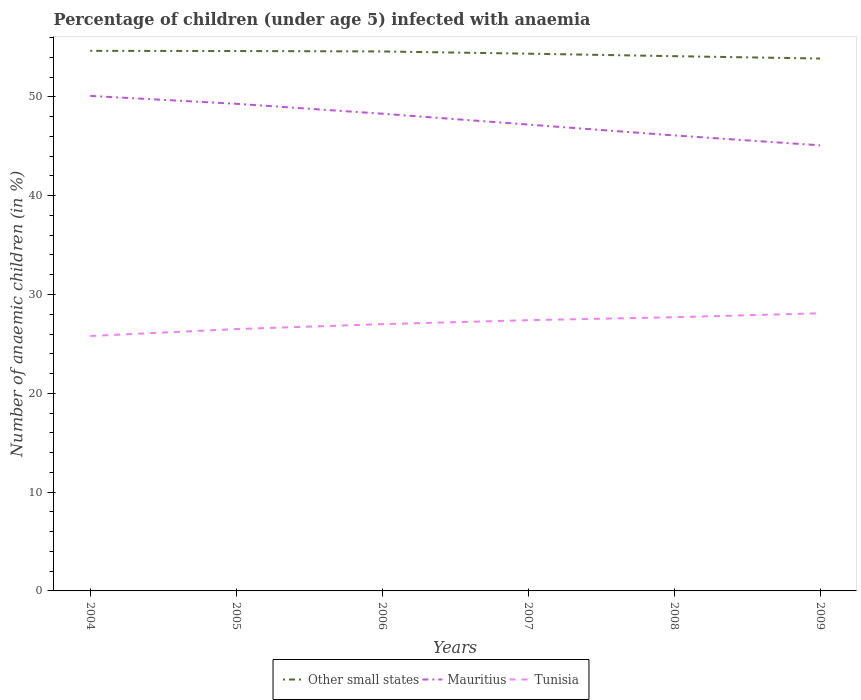How many different coloured lines are there?
Provide a short and direct response. 3. Does the line corresponding to Other small states intersect with the line corresponding to Mauritius?
Offer a very short reply. No. Across all years, what is the maximum percentage of children infected with anaemia in in Mauritius?
Your answer should be compact. 45.1. What is the total percentage of children infected with anaemia in in Mauritius in the graph?
Your answer should be compact. 2.9. What is the difference between the highest and the second highest percentage of children infected with anaemia in in Other small states?
Offer a very short reply. 0.78. Is the percentage of children infected with anaemia in in Mauritius strictly greater than the percentage of children infected with anaemia in in Tunisia over the years?
Offer a very short reply. No. How many lines are there?
Your response must be concise. 3. What is the difference between two consecutive major ticks on the Y-axis?
Provide a succinct answer. 10. Are the values on the major ticks of Y-axis written in scientific E-notation?
Your answer should be compact. No. Does the graph contain grids?
Offer a terse response. No. Where does the legend appear in the graph?
Offer a very short reply. Bottom center. What is the title of the graph?
Offer a terse response. Percentage of children (under age 5) infected with anaemia. What is the label or title of the X-axis?
Ensure brevity in your answer.  Years. What is the label or title of the Y-axis?
Give a very brief answer. Number of anaemic children (in %). What is the Number of anaemic children (in %) of Other small states in 2004?
Your answer should be very brief. 54.66. What is the Number of anaemic children (in %) of Mauritius in 2004?
Offer a very short reply. 50.1. What is the Number of anaemic children (in %) in Tunisia in 2004?
Give a very brief answer. 25.8. What is the Number of anaemic children (in %) in Other small states in 2005?
Your response must be concise. 54.64. What is the Number of anaemic children (in %) in Mauritius in 2005?
Provide a short and direct response. 49.3. What is the Number of anaemic children (in %) of Tunisia in 2005?
Keep it short and to the point. 26.5. What is the Number of anaemic children (in %) in Other small states in 2006?
Make the answer very short. 54.6. What is the Number of anaemic children (in %) in Mauritius in 2006?
Give a very brief answer. 48.3. What is the Number of anaemic children (in %) in Other small states in 2007?
Provide a short and direct response. 54.37. What is the Number of anaemic children (in %) in Mauritius in 2007?
Provide a short and direct response. 47.2. What is the Number of anaemic children (in %) in Tunisia in 2007?
Make the answer very short. 27.4. What is the Number of anaemic children (in %) of Other small states in 2008?
Keep it short and to the point. 54.12. What is the Number of anaemic children (in %) of Mauritius in 2008?
Ensure brevity in your answer.  46.1. What is the Number of anaemic children (in %) of Tunisia in 2008?
Provide a short and direct response. 27.7. What is the Number of anaemic children (in %) in Other small states in 2009?
Provide a succinct answer. 53.88. What is the Number of anaemic children (in %) in Mauritius in 2009?
Offer a very short reply. 45.1. What is the Number of anaemic children (in %) of Tunisia in 2009?
Provide a short and direct response. 28.1. Across all years, what is the maximum Number of anaemic children (in %) of Other small states?
Provide a short and direct response. 54.66. Across all years, what is the maximum Number of anaemic children (in %) of Mauritius?
Offer a terse response. 50.1. Across all years, what is the maximum Number of anaemic children (in %) of Tunisia?
Offer a very short reply. 28.1. Across all years, what is the minimum Number of anaemic children (in %) in Other small states?
Keep it short and to the point. 53.88. Across all years, what is the minimum Number of anaemic children (in %) of Mauritius?
Provide a short and direct response. 45.1. Across all years, what is the minimum Number of anaemic children (in %) in Tunisia?
Offer a terse response. 25.8. What is the total Number of anaemic children (in %) in Other small states in the graph?
Give a very brief answer. 326.28. What is the total Number of anaemic children (in %) of Mauritius in the graph?
Provide a succinct answer. 286.1. What is the total Number of anaemic children (in %) in Tunisia in the graph?
Your answer should be compact. 162.5. What is the difference between the Number of anaemic children (in %) in Other small states in 2004 and that in 2005?
Your answer should be very brief. 0.02. What is the difference between the Number of anaemic children (in %) in Tunisia in 2004 and that in 2005?
Provide a short and direct response. -0.7. What is the difference between the Number of anaemic children (in %) of Other small states in 2004 and that in 2006?
Offer a terse response. 0.06. What is the difference between the Number of anaemic children (in %) in Other small states in 2004 and that in 2007?
Provide a short and direct response. 0.29. What is the difference between the Number of anaemic children (in %) in Mauritius in 2004 and that in 2007?
Provide a succinct answer. 2.9. What is the difference between the Number of anaemic children (in %) in Other small states in 2004 and that in 2008?
Offer a very short reply. 0.54. What is the difference between the Number of anaemic children (in %) in Mauritius in 2004 and that in 2008?
Provide a short and direct response. 4. What is the difference between the Number of anaemic children (in %) in Tunisia in 2004 and that in 2008?
Provide a succinct answer. -1.9. What is the difference between the Number of anaemic children (in %) of Other small states in 2004 and that in 2009?
Offer a very short reply. 0.78. What is the difference between the Number of anaemic children (in %) in Mauritius in 2004 and that in 2009?
Keep it short and to the point. 5. What is the difference between the Number of anaemic children (in %) in Tunisia in 2004 and that in 2009?
Ensure brevity in your answer.  -2.3. What is the difference between the Number of anaemic children (in %) in Other small states in 2005 and that in 2006?
Offer a very short reply. 0.04. What is the difference between the Number of anaemic children (in %) in Mauritius in 2005 and that in 2006?
Offer a terse response. 1. What is the difference between the Number of anaemic children (in %) in Tunisia in 2005 and that in 2006?
Your response must be concise. -0.5. What is the difference between the Number of anaemic children (in %) of Other small states in 2005 and that in 2007?
Keep it short and to the point. 0.27. What is the difference between the Number of anaemic children (in %) of Other small states in 2005 and that in 2008?
Ensure brevity in your answer.  0.52. What is the difference between the Number of anaemic children (in %) in Mauritius in 2005 and that in 2008?
Make the answer very short. 3.2. What is the difference between the Number of anaemic children (in %) in Tunisia in 2005 and that in 2008?
Provide a succinct answer. -1.2. What is the difference between the Number of anaemic children (in %) of Other small states in 2005 and that in 2009?
Your answer should be compact. 0.76. What is the difference between the Number of anaemic children (in %) in Mauritius in 2005 and that in 2009?
Your answer should be very brief. 4.2. What is the difference between the Number of anaemic children (in %) in Other small states in 2006 and that in 2007?
Make the answer very short. 0.23. What is the difference between the Number of anaemic children (in %) of Mauritius in 2006 and that in 2007?
Keep it short and to the point. 1.1. What is the difference between the Number of anaemic children (in %) in Tunisia in 2006 and that in 2007?
Give a very brief answer. -0.4. What is the difference between the Number of anaemic children (in %) in Other small states in 2006 and that in 2008?
Your answer should be very brief. 0.48. What is the difference between the Number of anaemic children (in %) of Other small states in 2006 and that in 2009?
Make the answer very short. 0.72. What is the difference between the Number of anaemic children (in %) of Tunisia in 2006 and that in 2009?
Your response must be concise. -1.1. What is the difference between the Number of anaemic children (in %) of Other small states in 2007 and that in 2008?
Provide a succinct answer. 0.25. What is the difference between the Number of anaemic children (in %) in Tunisia in 2007 and that in 2008?
Your answer should be compact. -0.3. What is the difference between the Number of anaemic children (in %) in Other small states in 2007 and that in 2009?
Keep it short and to the point. 0.49. What is the difference between the Number of anaemic children (in %) in Tunisia in 2007 and that in 2009?
Your response must be concise. -0.7. What is the difference between the Number of anaemic children (in %) of Other small states in 2008 and that in 2009?
Your answer should be compact. 0.24. What is the difference between the Number of anaemic children (in %) of Mauritius in 2008 and that in 2009?
Offer a very short reply. 1. What is the difference between the Number of anaemic children (in %) of Tunisia in 2008 and that in 2009?
Your answer should be very brief. -0.4. What is the difference between the Number of anaemic children (in %) in Other small states in 2004 and the Number of anaemic children (in %) in Mauritius in 2005?
Offer a very short reply. 5.36. What is the difference between the Number of anaemic children (in %) in Other small states in 2004 and the Number of anaemic children (in %) in Tunisia in 2005?
Your answer should be very brief. 28.16. What is the difference between the Number of anaemic children (in %) in Mauritius in 2004 and the Number of anaemic children (in %) in Tunisia in 2005?
Offer a very short reply. 23.6. What is the difference between the Number of anaemic children (in %) of Other small states in 2004 and the Number of anaemic children (in %) of Mauritius in 2006?
Offer a terse response. 6.36. What is the difference between the Number of anaemic children (in %) of Other small states in 2004 and the Number of anaemic children (in %) of Tunisia in 2006?
Provide a succinct answer. 27.66. What is the difference between the Number of anaemic children (in %) in Mauritius in 2004 and the Number of anaemic children (in %) in Tunisia in 2006?
Make the answer very short. 23.1. What is the difference between the Number of anaemic children (in %) in Other small states in 2004 and the Number of anaemic children (in %) in Mauritius in 2007?
Keep it short and to the point. 7.46. What is the difference between the Number of anaemic children (in %) in Other small states in 2004 and the Number of anaemic children (in %) in Tunisia in 2007?
Keep it short and to the point. 27.26. What is the difference between the Number of anaemic children (in %) of Mauritius in 2004 and the Number of anaemic children (in %) of Tunisia in 2007?
Your response must be concise. 22.7. What is the difference between the Number of anaemic children (in %) of Other small states in 2004 and the Number of anaemic children (in %) of Mauritius in 2008?
Provide a short and direct response. 8.56. What is the difference between the Number of anaemic children (in %) of Other small states in 2004 and the Number of anaemic children (in %) of Tunisia in 2008?
Provide a succinct answer. 26.96. What is the difference between the Number of anaemic children (in %) of Mauritius in 2004 and the Number of anaemic children (in %) of Tunisia in 2008?
Make the answer very short. 22.4. What is the difference between the Number of anaemic children (in %) in Other small states in 2004 and the Number of anaemic children (in %) in Mauritius in 2009?
Provide a short and direct response. 9.56. What is the difference between the Number of anaemic children (in %) in Other small states in 2004 and the Number of anaemic children (in %) in Tunisia in 2009?
Your answer should be compact. 26.56. What is the difference between the Number of anaemic children (in %) in Mauritius in 2004 and the Number of anaemic children (in %) in Tunisia in 2009?
Give a very brief answer. 22. What is the difference between the Number of anaemic children (in %) in Other small states in 2005 and the Number of anaemic children (in %) in Mauritius in 2006?
Your response must be concise. 6.34. What is the difference between the Number of anaemic children (in %) of Other small states in 2005 and the Number of anaemic children (in %) of Tunisia in 2006?
Your answer should be compact. 27.64. What is the difference between the Number of anaemic children (in %) of Mauritius in 2005 and the Number of anaemic children (in %) of Tunisia in 2006?
Your response must be concise. 22.3. What is the difference between the Number of anaemic children (in %) in Other small states in 2005 and the Number of anaemic children (in %) in Mauritius in 2007?
Give a very brief answer. 7.44. What is the difference between the Number of anaemic children (in %) in Other small states in 2005 and the Number of anaemic children (in %) in Tunisia in 2007?
Keep it short and to the point. 27.24. What is the difference between the Number of anaemic children (in %) of Mauritius in 2005 and the Number of anaemic children (in %) of Tunisia in 2007?
Give a very brief answer. 21.9. What is the difference between the Number of anaemic children (in %) in Other small states in 2005 and the Number of anaemic children (in %) in Mauritius in 2008?
Provide a short and direct response. 8.54. What is the difference between the Number of anaemic children (in %) in Other small states in 2005 and the Number of anaemic children (in %) in Tunisia in 2008?
Make the answer very short. 26.94. What is the difference between the Number of anaemic children (in %) of Mauritius in 2005 and the Number of anaemic children (in %) of Tunisia in 2008?
Give a very brief answer. 21.6. What is the difference between the Number of anaemic children (in %) in Other small states in 2005 and the Number of anaemic children (in %) in Mauritius in 2009?
Your answer should be very brief. 9.54. What is the difference between the Number of anaemic children (in %) of Other small states in 2005 and the Number of anaemic children (in %) of Tunisia in 2009?
Offer a very short reply. 26.54. What is the difference between the Number of anaemic children (in %) of Mauritius in 2005 and the Number of anaemic children (in %) of Tunisia in 2009?
Ensure brevity in your answer.  21.2. What is the difference between the Number of anaemic children (in %) of Other small states in 2006 and the Number of anaemic children (in %) of Mauritius in 2007?
Provide a succinct answer. 7.4. What is the difference between the Number of anaemic children (in %) in Other small states in 2006 and the Number of anaemic children (in %) in Tunisia in 2007?
Ensure brevity in your answer.  27.2. What is the difference between the Number of anaemic children (in %) of Mauritius in 2006 and the Number of anaemic children (in %) of Tunisia in 2007?
Offer a terse response. 20.9. What is the difference between the Number of anaemic children (in %) of Other small states in 2006 and the Number of anaemic children (in %) of Mauritius in 2008?
Your answer should be compact. 8.5. What is the difference between the Number of anaemic children (in %) of Other small states in 2006 and the Number of anaemic children (in %) of Tunisia in 2008?
Your response must be concise. 26.9. What is the difference between the Number of anaemic children (in %) in Mauritius in 2006 and the Number of anaemic children (in %) in Tunisia in 2008?
Give a very brief answer. 20.6. What is the difference between the Number of anaemic children (in %) in Other small states in 2006 and the Number of anaemic children (in %) in Mauritius in 2009?
Offer a very short reply. 9.5. What is the difference between the Number of anaemic children (in %) in Other small states in 2006 and the Number of anaemic children (in %) in Tunisia in 2009?
Keep it short and to the point. 26.5. What is the difference between the Number of anaemic children (in %) of Mauritius in 2006 and the Number of anaemic children (in %) of Tunisia in 2009?
Provide a succinct answer. 20.2. What is the difference between the Number of anaemic children (in %) of Other small states in 2007 and the Number of anaemic children (in %) of Mauritius in 2008?
Ensure brevity in your answer.  8.27. What is the difference between the Number of anaemic children (in %) of Other small states in 2007 and the Number of anaemic children (in %) of Tunisia in 2008?
Ensure brevity in your answer.  26.67. What is the difference between the Number of anaemic children (in %) in Other small states in 2007 and the Number of anaemic children (in %) in Mauritius in 2009?
Offer a very short reply. 9.27. What is the difference between the Number of anaemic children (in %) of Other small states in 2007 and the Number of anaemic children (in %) of Tunisia in 2009?
Give a very brief answer. 26.27. What is the difference between the Number of anaemic children (in %) in Mauritius in 2007 and the Number of anaemic children (in %) in Tunisia in 2009?
Offer a terse response. 19.1. What is the difference between the Number of anaemic children (in %) of Other small states in 2008 and the Number of anaemic children (in %) of Mauritius in 2009?
Your response must be concise. 9.02. What is the difference between the Number of anaemic children (in %) in Other small states in 2008 and the Number of anaemic children (in %) in Tunisia in 2009?
Provide a succinct answer. 26.02. What is the average Number of anaemic children (in %) in Other small states per year?
Make the answer very short. 54.38. What is the average Number of anaemic children (in %) in Mauritius per year?
Your response must be concise. 47.68. What is the average Number of anaemic children (in %) in Tunisia per year?
Offer a terse response. 27.08. In the year 2004, what is the difference between the Number of anaemic children (in %) of Other small states and Number of anaemic children (in %) of Mauritius?
Give a very brief answer. 4.56. In the year 2004, what is the difference between the Number of anaemic children (in %) of Other small states and Number of anaemic children (in %) of Tunisia?
Your response must be concise. 28.86. In the year 2004, what is the difference between the Number of anaemic children (in %) in Mauritius and Number of anaemic children (in %) in Tunisia?
Offer a terse response. 24.3. In the year 2005, what is the difference between the Number of anaemic children (in %) of Other small states and Number of anaemic children (in %) of Mauritius?
Your answer should be compact. 5.34. In the year 2005, what is the difference between the Number of anaemic children (in %) in Other small states and Number of anaemic children (in %) in Tunisia?
Your answer should be very brief. 28.14. In the year 2005, what is the difference between the Number of anaemic children (in %) of Mauritius and Number of anaemic children (in %) of Tunisia?
Provide a short and direct response. 22.8. In the year 2006, what is the difference between the Number of anaemic children (in %) of Other small states and Number of anaemic children (in %) of Mauritius?
Your answer should be very brief. 6.3. In the year 2006, what is the difference between the Number of anaemic children (in %) in Other small states and Number of anaemic children (in %) in Tunisia?
Ensure brevity in your answer.  27.6. In the year 2006, what is the difference between the Number of anaemic children (in %) in Mauritius and Number of anaemic children (in %) in Tunisia?
Keep it short and to the point. 21.3. In the year 2007, what is the difference between the Number of anaemic children (in %) in Other small states and Number of anaemic children (in %) in Mauritius?
Offer a terse response. 7.17. In the year 2007, what is the difference between the Number of anaemic children (in %) in Other small states and Number of anaemic children (in %) in Tunisia?
Your answer should be very brief. 26.97. In the year 2007, what is the difference between the Number of anaemic children (in %) of Mauritius and Number of anaemic children (in %) of Tunisia?
Ensure brevity in your answer.  19.8. In the year 2008, what is the difference between the Number of anaemic children (in %) of Other small states and Number of anaemic children (in %) of Mauritius?
Your answer should be very brief. 8.02. In the year 2008, what is the difference between the Number of anaemic children (in %) in Other small states and Number of anaemic children (in %) in Tunisia?
Make the answer very short. 26.42. In the year 2008, what is the difference between the Number of anaemic children (in %) in Mauritius and Number of anaemic children (in %) in Tunisia?
Offer a terse response. 18.4. In the year 2009, what is the difference between the Number of anaemic children (in %) of Other small states and Number of anaemic children (in %) of Mauritius?
Offer a terse response. 8.78. In the year 2009, what is the difference between the Number of anaemic children (in %) of Other small states and Number of anaemic children (in %) of Tunisia?
Keep it short and to the point. 25.78. What is the ratio of the Number of anaemic children (in %) of Other small states in 2004 to that in 2005?
Offer a terse response. 1. What is the ratio of the Number of anaemic children (in %) of Mauritius in 2004 to that in 2005?
Provide a short and direct response. 1.02. What is the ratio of the Number of anaemic children (in %) of Tunisia in 2004 to that in 2005?
Make the answer very short. 0.97. What is the ratio of the Number of anaemic children (in %) of Mauritius in 2004 to that in 2006?
Give a very brief answer. 1.04. What is the ratio of the Number of anaemic children (in %) of Tunisia in 2004 to that in 2006?
Offer a terse response. 0.96. What is the ratio of the Number of anaemic children (in %) in Mauritius in 2004 to that in 2007?
Provide a succinct answer. 1.06. What is the ratio of the Number of anaemic children (in %) in Tunisia in 2004 to that in 2007?
Your answer should be very brief. 0.94. What is the ratio of the Number of anaemic children (in %) of Other small states in 2004 to that in 2008?
Your answer should be very brief. 1.01. What is the ratio of the Number of anaemic children (in %) in Mauritius in 2004 to that in 2008?
Make the answer very short. 1.09. What is the ratio of the Number of anaemic children (in %) of Tunisia in 2004 to that in 2008?
Ensure brevity in your answer.  0.93. What is the ratio of the Number of anaemic children (in %) of Other small states in 2004 to that in 2009?
Provide a short and direct response. 1.01. What is the ratio of the Number of anaemic children (in %) in Mauritius in 2004 to that in 2009?
Offer a very short reply. 1.11. What is the ratio of the Number of anaemic children (in %) in Tunisia in 2004 to that in 2009?
Offer a very short reply. 0.92. What is the ratio of the Number of anaemic children (in %) of Mauritius in 2005 to that in 2006?
Keep it short and to the point. 1.02. What is the ratio of the Number of anaemic children (in %) of Tunisia in 2005 to that in 2006?
Your response must be concise. 0.98. What is the ratio of the Number of anaemic children (in %) of Mauritius in 2005 to that in 2007?
Keep it short and to the point. 1.04. What is the ratio of the Number of anaemic children (in %) of Tunisia in 2005 to that in 2007?
Keep it short and to the point. 0.97. What is the ratio of the Number of anaemic children (in %) of Other small states in 2005 to that in 2008?
Provide a short and direct response. 1.01. What is the ratio of the Number of anaemic children (in %) of Mauritius in 2005 to that in 2008?
Keep it short and to the point. 1.07. What is the ratio of the Number of anaemic children (in %) in Tunisia in 2005 to that in 2008?
Provide a short and direct response. 0.96. What is the ratio of the Number of anaemic children (in %) of Other small states in 2005 to that in 2009?
Keep it short and to the point. 1.01. What is the ratio of the Number of anaemic children (in %) in Mauritius in 2005 to that in 2009?
Your answer should be very brief. 1.09. What is the ratio of the Number of anaemic children (in %) in Tunisia in 2005 to that in 2009?
Offer a very short reply. 0.94. What is the ratio of the Number of anaemic children (in %) in Mauritius in 2006 to that in 2007?
Ensure brevity in your answer.  1.02. What is the ratio of the Number of anaemic children (in %) of Tunisia in 2006 to that in 2007?
Your answer should be compact. 0.99. What is the ratio of the Number of anaemic children (in %) of Other small states in 2006 to that in 2008?
Your response must be concise. 1.01. What is the ratio of the Number of anaemic children (in %) of Mauritius in 2006 to that in 2008?
Offer a terse response. 1.05. What is the ratio of the Number of anaemic children (in %) in Tunisia in 2006 to that in 2008?
Your answer should be very brief. 0.97. What is the ratio of the Number of anaemic children (in %) in Other small states in 2006 to that in 2009?
Provide a short and direct response. 1.01. What is the ratio of the Number of anaemic children (in %) in Mauritius in 2006 to that in 2009?
Your answer should be compact. 1.07. What is the ratio of the Number of anaemic children (in %) in Tunisia in 2006 to that in 2009?
Provide a succinct answer. 0.96. What is the ratio of the Number of anaemic children (in %) of Other small states in 2007 to that in 2008?
Offer a very short reply. 1. What is the ratio of the Number of anaemic children (in %) in Mauritius in 2007 to that in 2008?
Your answer should be compact. 1.02. What is the ratio of the Number of anaemic children (in %) of Other small states in 2007 to that in 2009?
Give a very brief answer. 1.01. What is the ratio of the Number of anaemic children (in %) of Mauritius in 2007 to that in 2009?
Offer a very short reply. 1.05. What is the ratio of the Number of anaemic children (in %) of Tunisia in 2007 to that in 2009?
Make the answer very short. 0.98. What is the ratio of the Number of anaemic children (in %) in Mauritius in 2008 to that in 2009?
Keep it short and to the point. 1.02. What is the ratio of the Number of anaemic children (in %) in Tunisia in 2008 to that in 2009?
Provide a short and direct response. 0.99. What is the difference between the highest and the second highest Number of anaemic children (in %) of Other small states?
Offer a very short reply. 0.02. What is the difference between the highest and the second highest Number of anaemic children (in %) of Mauritius?
Give a very brief answer. 0.8. What is the difference between the highest and the lowest Number of anaemic children (in %) in Other small states?
Your answer should be very brief. 0.78. What is the difference between the highest and the lowest Number of anaemic children (in %) of Tunisia?
Provide a succinct answer. 2.3. 